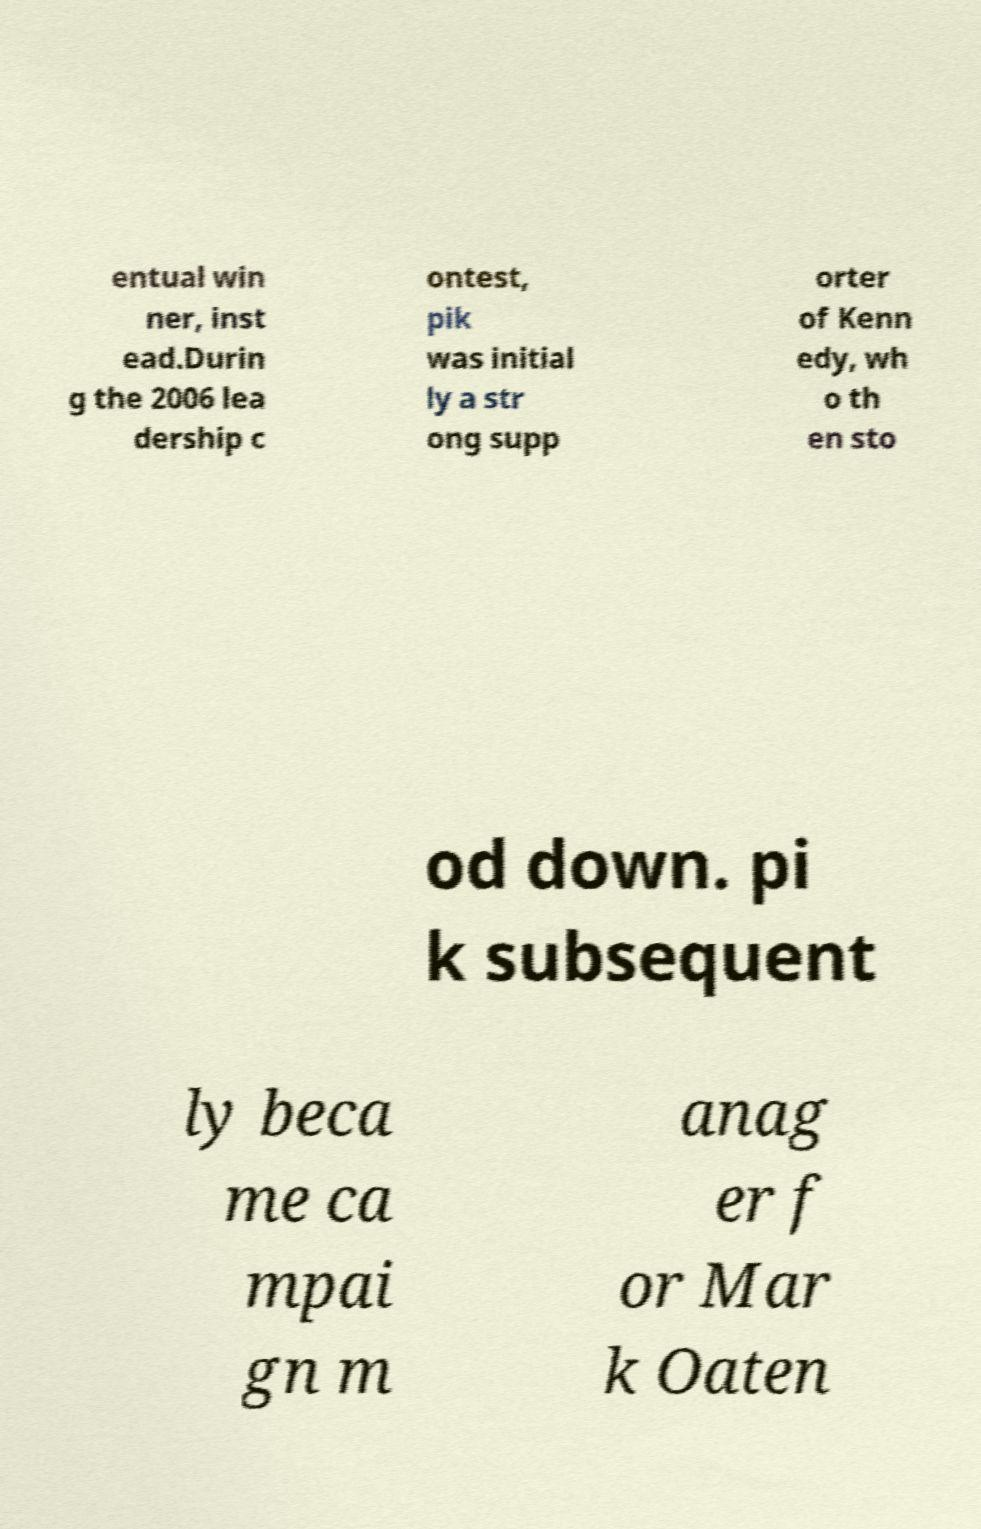Please identify and transcribe the text found in this image. entual win ner, inst ead.Durin g the 2006 lea dership c ontest, pik was initial ly a str ong supp orter of Kenn edy, wh o th en sto od down. pi k subsequent ly beca me ca mpai gn m anag er f or Mar k Oaten 